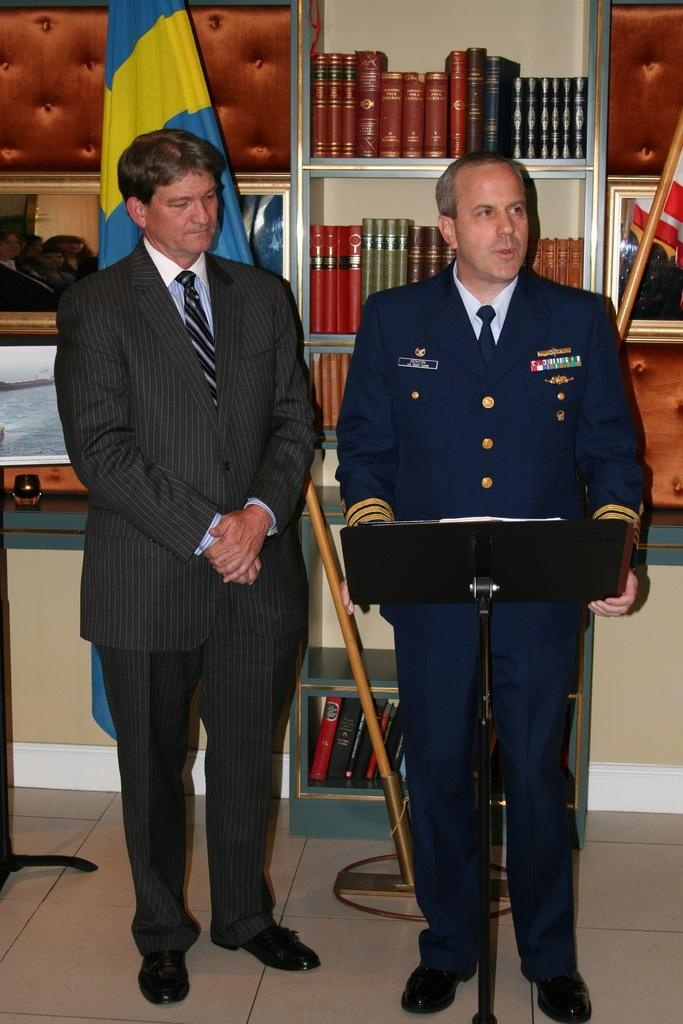How many people are in the image? There are two people standing in the image. What can be seen besides the people in the image? There is a flag visible in the image, as well as bookshelves and books. What type of structure is made of zinc in the image? There is no structure made of zinc present in the image. What action are the two people performing in the image? The provided facts do not specify any actions being performed by the two people in the image. 